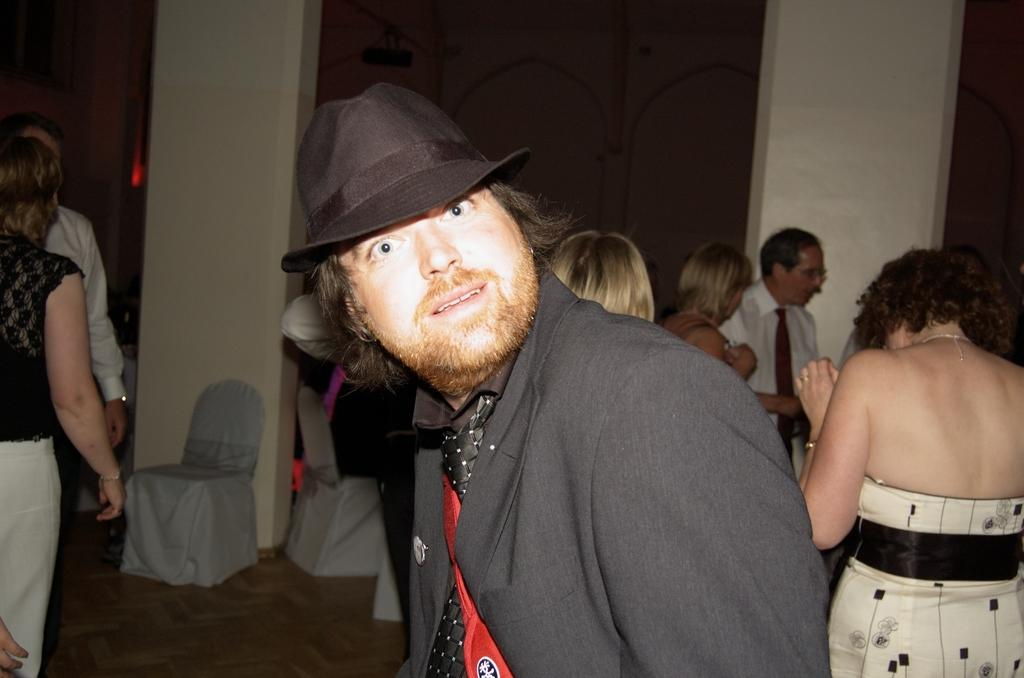Who is the main subject in the image? There is a man in the center of the image. Can you describe the surroundings of the man? There are other people and chairs in the background of the image. What architectural features are present in the background? There are pillars in the background of the image. What type of harmony can be heard in the image? There is no audible sound or music in the image, so it is not possible to determine the type of harmony. 